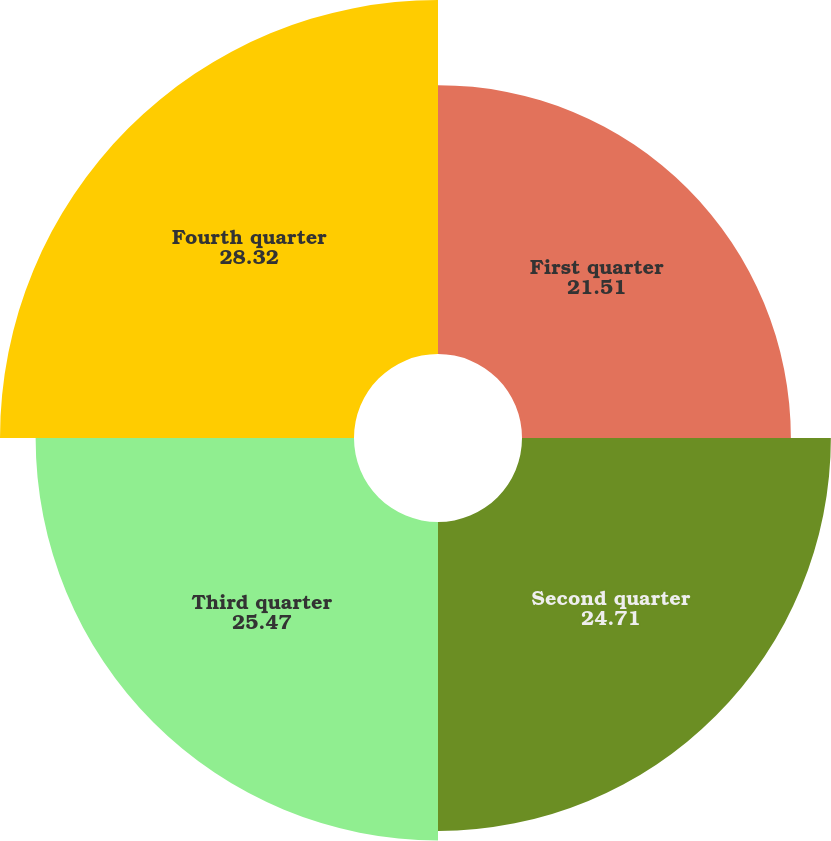<chart> <loc_0><loc_0><loc_500><loc_500><pie_chart><fcel>First quarter<fcel>Second quarter<fcel>Third quarter<fcel>Fourth quarter<nl><fcel>21.51%<fcel>24.71%<fcel>25.47%<fcel>28.32%<nl></chart> 